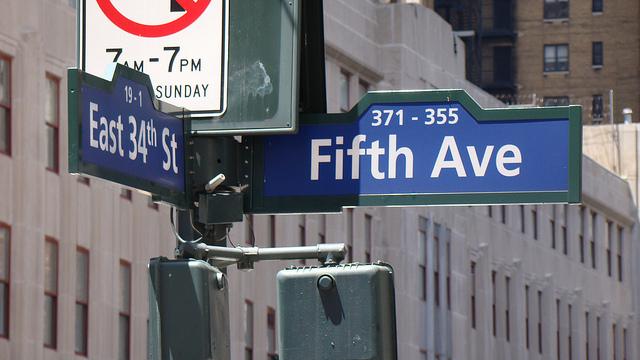Is this a corner street?
Give a very brief answer. Yes. Is this small town America?
Quick response, please. No. What is the number of fifth Ave?
Answer briefly. 371-355. 